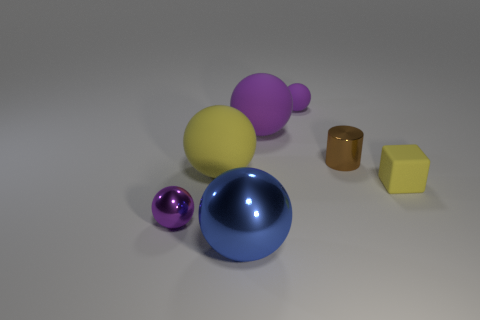There is a tiny block; is its color the same as the matte sphere that is on the left side of the big purple rubber sphere?
Keep it short and to the point. Yes. What is the size of the rubber ball that is the same color as the small matte block?
Make the answer very short. Large. What number of things are brown objects or yellow rubber objects?
Give a very brief answer. 3. There is a big object that is both in front of the small shiny cylinder and behind the blue ball; what shape is it?
Your answer should be very brief. Sphere. Does the small yellow rubber thing have the same shape as the yellow object left of the tiny brown metallic object?
Ensure brevity in your answer.  No. There is a rubber cube; are there any objects behind it?
Provide a succinct answer. Yes. What material is the big object that is the same color as the tiny rubber cube?
Your answer should be compact. Rubber. How many spheres are either purple shiny things or rubber things?
Keep it short and to the point. 4. Does the big blue metal object have the same shape as the small purple shiny object?
Ensure brevity in your answer.  Yes. There is a purple sphere that is to the left of the blue shiny ball; what is its size?
Your answer should be compact. Small. 